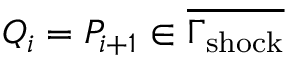<formula> <loc_0><loc_0><loc_500><loc_500>Q _ { i } = P _ { i + 1 } \in \overline { { \Gamma _ { s h o c k } } }</formula> 